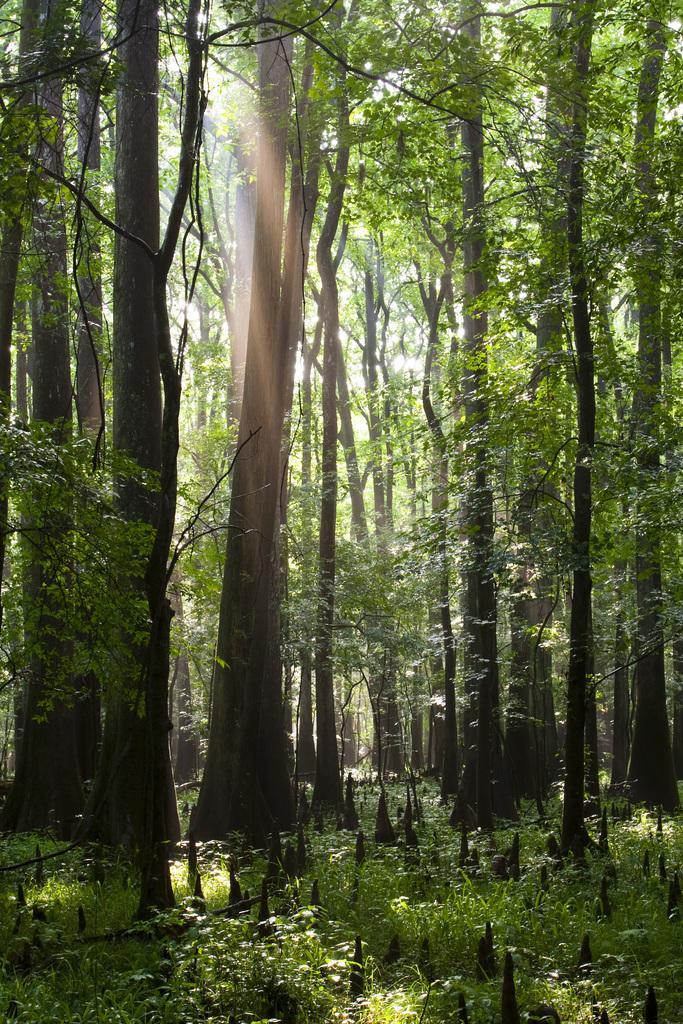Could you give a brief overview of what you see in this image? In this image I can see some grass and few black colored objects on the ground. I can see few trees which are green and black in color and in the background I can see the sky. 